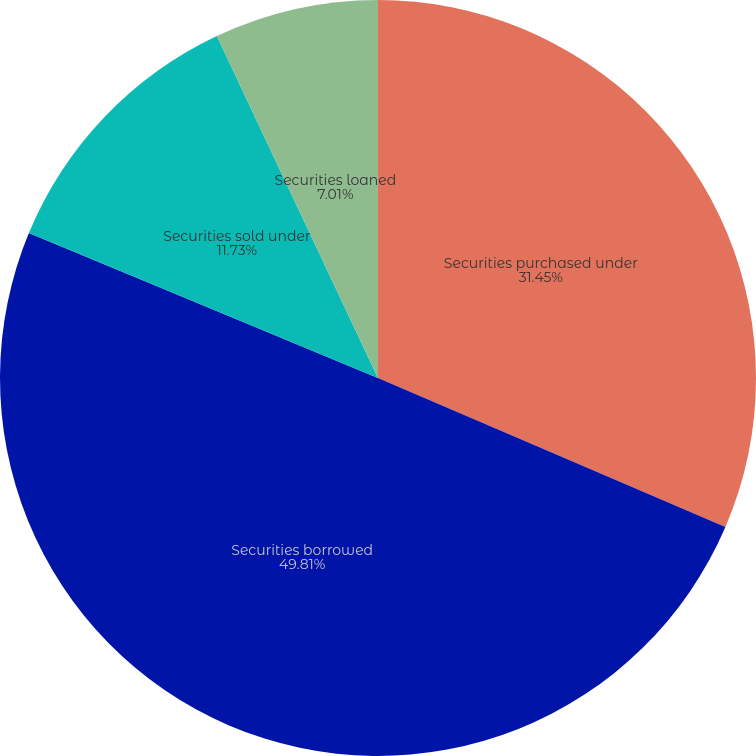<chart> <loc_0><loc_0><loc_500><loc_500><pie_chart><fcel>Securities purchased under<fcel>Securities borrowed<fcel>Securities sold under<fcel>Securities loaned<nl><fcel>31.45%<fcel>49.82%<fcel>11.73%<fcel>7.01%<nl></chart> 